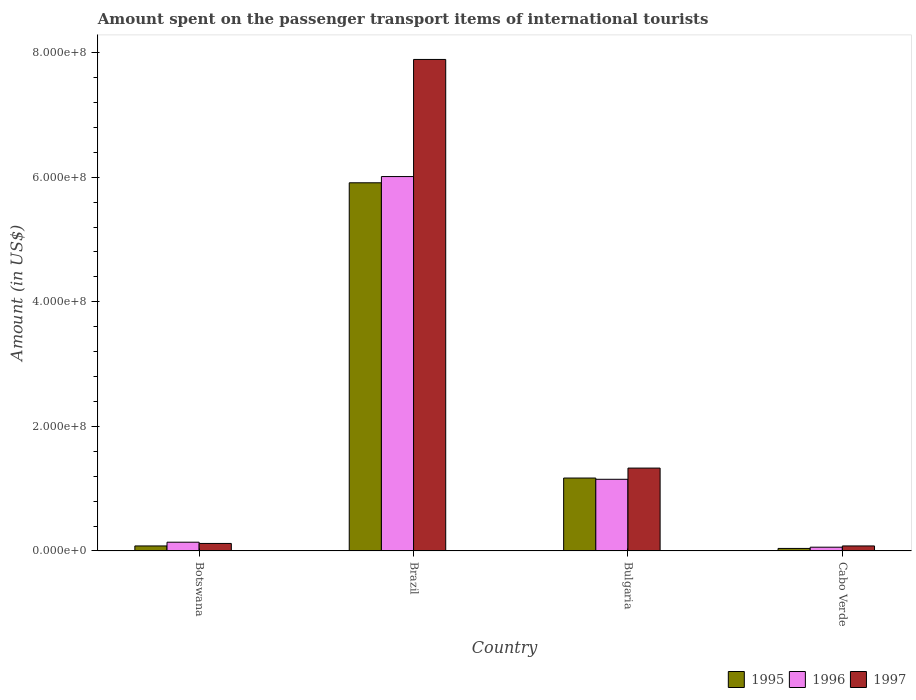How many different coloured bars are there?
Your answer should be very brief. 3. How many groups of bars are there?
Ensure brevity in your answer.  4. How many bars are there on the 2nd tick from the left?
Provide a succinct answer. 3. How many bars are there on the 1st tick from the right?
Offer a very short reply. 3. What is the label of the 4th group of bars from the left?
Provide a succinct answer. Cabo Verde. What is the amount spent on the passenger transport items of international tourists in 1996 in Bulgaria?
Ensure brevity in your answer.  1.15e+08. Across all countries, what is the maximum amount spent on the passenger transport items of international tourists in 1996?
Provide a succinct answer. 6.01e+08. In which country was the amount spent on the passenger transport items of international tourists in 1995 minimum?
Your answer should be very brief. Cabo Verde. What is the total amount spent on the passenger transport items of international tourists in 1996 in the graph?
Provide a succinct answer. 7.36e+08. What is the difference between the amount spent on the passenger transport items of international tourists in 1997 in Botswana and that in Bulgaria?
Offer a terse response. -1.21e+08. What is the difference between the amount spent on the passenger transport items of international tourists in 1995 in Brazil and the amount spent on the passenger transport items of international tourists in 1997 in Botswana?
Your answer should be compact. 5.79e+08. What is the average amount spent on the passenger transport items of international tourists in 1995 per country?
Offer a very short reply. 1.80e+08. In how many countries, is the amount spent on the passenger transport items of international tourists in 1996 greater than 440000000 US$?
Give a very brief answer. 1. What is the ratio of the amount spent on the passenger transport items of international tourists in 1996 in Brazil to that in Bulgaria?
Provide a succinct answer. 5.23. What is the difference between the highest and the second highest amount spent on the passenger transport items of international tourists in 1995?
Provide a succinct answer. 5.83e+08. What is the difference between the highest and the lowest amount spent on the passenger transport items of international tourists in 1996?
Give a very brief answer. 5.95e+08. Is the sum of the amount spent on the passenger transport items of international tourists in 1996 in Botswana and Brazil greater than the maximum amount spent on the passenger transport items of international tourists in 1995 across all countries?
Your answer should be very brief. Yes. Is it the case that in every country, the sum of the amount spent on the passenger transport items of international tourists in 1995 and amount spent on the passenger transport items of international tourists in 1996 is greater than the amount spent on the passenger transport items of international tourists in 1997?
Your response must be concise. Yes. What is the difference between two consecutive major ticks on the Y-axis?
Ensure brevity in your answer.  2.00e+08. How many legend labels are there?
Make the answer very short. 3. How are the legend labels stacked?
Make the answer very short. Horizontal. What is the title of the graph?
Give a very brief answer. Amount spent on the passenger transport items of international tourists. Does "2008" appear as one of the legend labels in the graph?
Your answer should be very brief. No. What is the label or title of the X-axis?
Your answer should be compact. Country. What is the Amount (in US$) in 1995 in Botswana?
Your answer should be compact. 8.00e+06. What is the Amount (in US$) in 1996 in Botswana?
Offer a very short reply. 1.40e+07. What is the Amount (in US$) in 1995 in Brazil?
Provide a succinct answer. 5.91e+08. What is the Amount (in US$) in 1996 in Brazil?
Offer a terse response. 6.01e+08. What is the Amount (in US$) of 1997 in Brazil?
Keep it short and to the point. 7.89e+08. What is the Amount (in US$) of 1995 in Bulgaria?
Your answer should be compact. 1.17e+08. What is the Amount (in US$) in 1996 in Bulgaria?
Make the answer very short. 1.15e+08. What is the Amount (in US$) in 1997 in Bulgaria?
Your response must be concise. 1.33e+08. What is the Amount (in US$) of 1995 in Cabo Verde?
Offer a terse response. 4.00e+06. Across all countries, what is the maximum Amount (in US$) of 1995?
Make the answer very short. 5.91e+08. Across all countries, what is the maximum Amount (in US$) in 1996?
Provide a succinct answer. 6.01e+08. Across all countries, what is the maximum Amount (in US$) in 1997?
Provide a short and direct response. 7.89e+08. Across all countries, what is the minimum Amount (in US$) of 1996?
Offer a terse response. 6.00e+06. Across all countries, what is the minimum Amount (in US$) of 1997?
Your answer should be compact. 8.00e+06. What is the total Amount (in US$) of 1995 in the graph?
Ensure brevity in your answer.  7.20e+08. What is the total Amount (in US$) in 1996 in the graph?
Your answer should be very brief. 7.36e+08. What is the total Amount (in US$) of 1997 in the graph?
Offer a terse response. 9.42e+08. What is the difference between the Amount (in US$) of 1995 in Botswana and that in Brazil?
Your answer should be compact. -5.83e+08. What is the difference between the Amount (in US$) of 1996 in Botswana and that in Brazil?
Provide a short and direct response. -5.87e+08. What is the difference between the Amount (in US$) of 1997 in Botswana and that in Brazil?
Provide a short and direct response. -7.77e+08. What is the difference between the Amount (in US$) of 1995 in Botswana and that in Bulgaria?
Give a very brief answer. -1.09e+08. What is the difference between the Amount (in US$) in 1996 in Botswana and that in Bulgaria?
Provide a succinct answer. -1.01e+08. What is the difference between the Amount (in US$) in 1997 in Botswana and that in Bulgaria?
Offer a very short reply. -1.21e+08. What is the difference between the Amount (in US$) of 1995 in Botswana and that in Cabo Verde?
Your answer should be very brief. 4.00e+06. What is the difference between the Amount (in US$) in 1996 in Botswana and that in Cabo Verde?
Keep it short and to the point. 8.00e+06. What is the difference between the Amount (in US$) of 1995 in Brazil and that in Bulgaria?
Your response must be concise. 4.74e+08. What is the difference between the Amount (in US$) of 1996 in Brazil and that in Bulgaria?
Make the answer very short. 4.86e+08. What is the difference between the Amount (in US$) in 1997 in Brazil and that in Bulgaria?
Keep it short and to the point. 6.56e+08. What is the difference between the Amount (in US$) in 1995 in Brazil and that in Cabo Verde?
Offer a terse response. 5.87e+08. What is the difference between the Amount (in US$) in 1996 in Brazil and that in Cabo Verde?
Give a very brief answer. 5.95e+08. What is the difference between the Amount (in US$) of 1997 in Brazil and that in Cabo Verde?
Ensure brevity in your answer.  7.81e+08. What is the difference between the Amount (in US$) of 1995 in Bulgaria and that in Cabo Verde?
Give a very brief answer. 1.13e+08. What is the difference between the Amount (in US$) of 1996 in Bulgaria and that in Cabo Verde?
Make the answer very short. 1.09e+08. What is the difference between the Amount (in US$) in 1997 in Bulgaria and that in Cabo Verde?
Keep it short and to the point. 1.25e+08. What is the difference between the Amount (in US$) of 1995 in Botswana and the Amount (in US$) of 1996 in Brazil?
Your answer should be very brief. -5.93e+08. What is the difference between the Amount (in US$) in 1995 in Botswana and the Amount (in US$) in 1997 in Brazil?
Give a very brief answer. -7.81e+08. What is the difference between the Amount (in US$) of 1996 in Botswana and the Amount (in US$) of 1997 in Brazil?
Offer a very short reply. -7.75e+08. What is the difference between the Amount (in US$) in 1995 in Botswana and the Amount (in US$) in 1996 in Bulgaria?
Your answer should be compact. -1.07e+08. What is the difference between the Amount (in US$) in 1995 in Botswana and the Amount (in US$) in 1997 in Bulgaria?
Your response must be concise. -1.25e+08. What is the difference between the Amount (in US$) of 1996 in Botswana and the Amount (in US$) of 1997 in Bulgaria?
Offer a very short reply. -1.19e+08. What is the difference between the Amount (in US$) of 1995 in Botswana and the Amount (in US$) of 1996 in Cabo Verde?
Your response must be concise. 2.00e+06. What is the difference between the Amount (in US$) in 1995 in Botswana and the Amount (in US$) in 1997 in Cabo Verde?
Ensure brevity in your answer.  0. What is the difference between the Amount (in US$) of 1995 in Brazil and the Amount (in US$) of 1996 in Bulgaria?
Your answer should be compact. 4.76e+08. What is the difference between the Amount (in US$) in 1995 in Brazil and the Amount (in US$) in 1997 in Bulgaria?
Provide a succinct answer. 4.58e+08. What is the difference between the Amount (in US$) of 1996 in Brazil and the Amount (in US$) of 1997 in Bulgaria?
Offer a very short reply. 4.68e+08. What is the difference between the Amount (in US$) of 1995 in Brazil and the Amount (in US$) of 1996 in Cabo Verde?
Keep it short and to the point. 5.85e+08. What is the difference between the Amount (in US$) of 1995 in Brazil and the Amount (in US$) of 1997 in Cabo Verde?
Your answer should be compact. 5.83e+08. What is the difference between the Amount (in US$) in 1996 in Brazil and the Amount (in US$) in 1997 in Cabo Verde?
Provide a short and direct response. 5.93e+08. What is the difference between the Amount (in US$) in 1995 in Bulgaria and the Amount (in US$) in 1996 in Cabo Verde?
Offer a very short reply. 1.11e+08. What is the difference between the Amount (in US$) in 1995 in Bulgaria and the Amount (in US$) in 1997 in Cabo Verde?
Ensure brevity in your answer.  1.09e+08. What is the difference between the Amount (in US$) of 1996 in Bulgaria and the Amount (in US$) of 1997 in Cabo Verde?
Keep it short and to the point. 1.07e+08. What is the average Amount (in US$) in 1995 per country?
Offer a very short reply. 1.80e+08. What is the average Amount (in US$) of 1996 per country?
Your response must be concise. 1.84e+08. What is the average Amount (in US$) in 1997 per country?
Offer a very short reply. 2.36e+08. What is the difference between the Amount (in US$) in 1995 and Amount (in US$) in 1996 in Botswana?
Your answer should be very brief. -6.00e+06. What is the difference between the Amount (in US$) in 1996 and Amount (in US$) in 1997 in Botswana?
Keep it short and to the point. 2.00e+06. What is the difference between the Amount (in US$) of 1995 and Amount (in US$) of 1996 in Brazil?
Keep it short and to the point. -1.00e+07. What is the difference between the Amount (in US$) of 1995 and Amount (in US$) of 1997 in Brazil?
Give a very brief answer. -1.98e+08. What is the difference between the Amount (in US$) in 1996 and Amount (in US$) in 1997 in Brazil?
Offer a terse response. -1.88e+08. What is the difference between the Amount (in US$) of 1995 and Amount (in US$) of 1996 in Bulgaria?
Keep it short and to the point. 2.00e+06. What is the difference between the Amount (in US$) of 1995 and Amount (in US$) of 1997 in Bulgaria?
Offer a terse response. -1.60e+07. What is the difference between the Amount (in US$) in 1996 and Amount (in US$) in 1997 in Bulgaria?
Offer a very short reply. -1.80e+07. What is the difference between the Amount (in US$) in 1995 and Amount (in US$) in 1997 in Cabo Verde?
Your answer should be compact. -4.00e+06. What is the ratio of the Amount (in US$) in 1995 in Botswana to that in Brazil?
Your answer should be very brief. 0.01. What is the ratio of the Amount (in US$) of 1996 in Botswana to that in Brazil?
Offer a terse response. 0.02. What is the ratio of the Amount (in US$) in 1997 in Botswana to that in Brazil?
Ensure brevity in your answer.  0.02. What is the ratio of the Amount (in US$) in 1995 in Botswana to that in Bulgaria?
Keep it short and to the point. 0.07. What is the ratio of the Amount (in US$) in 1996 in Botswana to that in Bulgaria?
Your answer should be very brief. 0.12. What is the ratio of the Amount (in US$) in 1997 in Botswana to that in Bulgaria?
Your answer should be compact. 0.09. What is the ratio of the Amount (in US$) in 1995 in Botswana to that in Cabo Verde?
Provide a succinct answer. 2. What is the ratio of the Amount (in US$) in 1996 in Botswana to that in Cabo Verde?
Provide a succinct answer. 2.33. What is the ratio of the Amount (in US$) in 1997 in Botswana to that in Cabo Verde?
Give a very brief answer. 1.5. What is the ratio of the Amount (in US$) in 1995 in Brazil to that in Bulgaria?
Offer a very short reply. 5.05. What is the ratio of the Amount (in US$) of 1996 in Brazil to that in Bulgaria?
Ensure brevity in your answer.  5.23. What is the ratio of the Amount (in US$) in 1997 in Brazil to that in Bulgaria?
Provide a short and direct response. 5.93. What is the ratio of the Amount (in US$) of 1995 in Brazil to that in Cabo Verde?
Offer a very short reply. 147.75. What is the ratio of the Amount (in US$) in 1996 in Brazil to that in Cabo Verde?
Provide a short and direct response. 100.17. What is the ratio of the Amount (in US$) of 1997 in Brazil to that in Cabo Verde?
Offer a very short reply. 98.62. What is the ratio of the Amount (in US$) of 1995 in Bulgaria to that in Cabo Verde?
Your response must be concise. 29.25. What is the ratio of the Amount (in US$) in 1996 in Bulgaria to that in Cabo Verde?
Give a very brief answer. 19.17. What is the ratio of the Amount (in US$) of 1997 in Bulgaria to that in Cabo Verde?
Your answer should be very brief. 16.62. What is the difference between the highest and the second highest Amount (in US$) of 1995?
Offer a very short reply. 4.74e+08. What is the difference between the highest and the second highest Amount (in US$) in 1996?
Give a very brief answer. 4.86e+08. What is the difference between the highest and the second highest Amount (in US$) of 1997?
Give a very brief answer. 6.56e+08. What is the difference between the highest and the lowest Amount (in US$) of 1995?
Ensure brevity in your answer.  5.87e+08. What is the difference between the highest and the lowest Amount (in US$) of 1996?
Your answer should be very brief. 5.95e+08. What is the difference between the highest and the lowest Amount (in US$) in 1997?
Make the answer very short. 7.81e+08. 